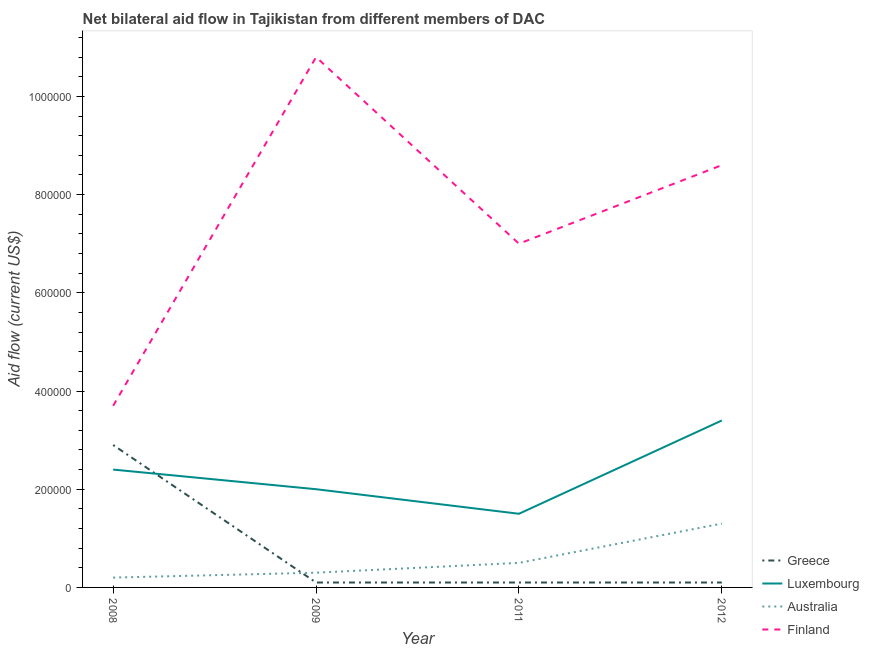Does the line corresponding to amount of aid given by finland intersect with the line corresponding to amount of aid given by luxembourg?
Your response must be concise. No. What is the amount of aid given by luxembourg in 2012?
Give a very brief answer. 3.40e+05. Across all years, what is the maximum amount of aid given by australia?
Keep it short and to the point. 1.30e+05. Across all years, what is the minimum amount of aid given by greece?
Your answer should be very brief. 10000. In which year was the amount of aid given by australia maximum?
Your answer should be very brief. 2012. What is the total amount of aid given by greece in the graph?
Make the answer very short. 3.20e+05. What is the difference between the amount of aid given by greece in 2008 and that in 2009?
Give a very brief answer. 2.80e+05. What is the difference between the amount of aid given by greece in 2009 and the amount of aid given by finland in 2008?
Provide a succinct answer. -3.60e+05. What is the average amount of aid given by australia per year?
Make the answer very short. 5.75e+04. In the year 2009, what is the difference between the amount of aid given by greece and amount of aid given by luxembourg?
Ensure brevity in your answer.  -1.90e+05. What is the ratio of the amount of aid given by finland in 2008 to that in 2009?
Offer a very short reply. 0.34. Is the amount of aid given by luxembourg in 2009 less than that in 2012?
Offer a very short reply. Yes. Is the difference between the amount of aid given by australia in 2009 and 2011 greater than the difference between the amount of aid given by greece in 2009 and 2011?
Offer a very short reply. No. What is the difference between the highest and the second highest amount of aid given by finland?
Provide a succinct answer. 2.20e+05. What is the difference between the highest and the lowest amount of aid given by luxembourg?
Ensure brevity in your answer.  1.90e+05. Is the sum of the amount of aid given by greece in 2009 and 2011 greater than the maximum amount of aid given by australia across all years?
Give a very brief answer. No. Is it the case that in every year, the sum of the amount of aid given by greece and amount of aid given by australia is greater than the sum of amount of aid given by luxembourg and amount of aid given by finland?
Provide a succinct answer. Yes. Does the amount of aid given by australia monotonically increase over the years?
Offer a very short reply. Yes. Is the amount of aid given by australia strictly greater than the amount of aid given by luxembourg over the years?
Your response must be concise. No. Is the amount of aid given by luxembourg strictly less than the amount of aid given by greece over the years?
Your response must be concise. No. How many years are there in the graph?
Ensure brevity in your answer.  4. What is the difference between two consecutive major ticks on the Y-axis?
Offer a very short reply. 2.00e+05. Does the graph contain any zero values?
Your response must be concise. No. Does the graph contain grids?
Offer a very short reply. No. How many legend labels are there?
Ensure brevity in your answer.  4. How are the legend labels stacked?
Provide a short and direct response. Vertical. What is the title of the graph?
Ensure brevity in your answer.  Net bilateral aid flow in Tajikistan from different members of DAC. What is the label or title of the Y-axis?
Offer a very short reply. Aid flow (current US$). What is the Aid flow (current US$) of Greece in 2008?
Ensure brevity in your answer.  2.90e+05. What is the Aid flow (current US$) in Luxembourg in 2008?
Your response must be concise. 2.40e+05. What is the Aid flow (current US$) of Finland in 2008?
Ensure brevity in your answer.  3.70e+05. What is the Aid flow (current US$) of Greece in 2009?
Ensure brevity in your answer.  10000. What is the Aid flow (current US$) of Australia in 2009?
Give a very brief answer. 3.00e+04. What is the Aid flow (current US$) of Finland in 2009?
Make the answer very short. 1.08e+06. What is the Aid flow (current US$) of Finland in 2011?
Ensure brevity in your answer.  7.00e+05. What is the Aid flow (current US$) in Greece in 2012?
Provide a succinct answer. 10000. What is the Aid flow (current US$) of Finland in 2012?
Ensure brevity in your answer.  8.60e+05. Across all years, what is the maximum Aid flow (current US$) of Luxembourg?
Offer a very short reply. 3.40e+05. Across all years, what is the maximum Aid flow (current US$) in Finland?
Give a very brief answer. 1.08e+06. Across all years, what is the minimum Aid flow (current US$) in Greece?
Offer a terse response. 10000. What is the total Aid flow (current US$) in Luxembourg in the graph?
Give a very brief answer. 9.30e+05. What is the total Aid flow (current US$) of Australia in the graph?
Make the answer very short. 2.30e+05. What is the total Aid flow (current US$) of Finland in the graph?
Your answer should be very brief. 3.01e+06. What is the difference between the Aid flow (current US$) of Finland in 2008 and that in 2009?
Your answer should be very brief. -7.10e+05. What is the difference between the Aid flow (current US$) in Greece in 2008 and that in 2011?
Provide a succinct answer. 2.80e+05. What is the difference between the Aid flow (current US$) of Luxembourg in 2008 and that in 2011?
Ensure brevity in your answer.  9.00e+04. What is the difference between the Aid flow (current US$) of Australia in 2008 and that in 2011?
Provide a succinct answer. -3.00e+04. What is the difference between the Aid flow (current US$) in Finland in 2008 and that in 2011?
Provide a short and direct response. -3.30e+05. What is the difference between the Aid flow (current US$) of Luxembourg in 2008 and that in 2012?
Make the answer very short. -1.00e+05. What is the difference between the Aid flow (current US$) in Australia in 2008 and that in 2012?
Your answer should be compact. -1.10e+05. What is the difference between the Aid flow (current US$) in Finland in 2008 and that in 2012?
Your response must be concise. -4.90e+05. What is the difference between the Aid flow (current US$) of Greece in 2009 and that in 2011?
Give a very brief answer. 0. What is the difference between the Aid flow (current US$) of Finland in 2009 and that in 2011?
Your response must be concise. 3.80e+05. What is the difference between the Aid flow (current US$) in Luxembourg in 2009 and that in 2012?
Your answer should be compact. -1.40e+05. What is the difference between the Aid flow (current US$) in Australia in 2009 and that in 2012?
Provide a short and direct response. -1.00e+05. What is the difference between the Aid flow (current US$) of Finland in 2009 and that in 2012?
Offer a very short reply. 2.20e+05. What is the difference between the Aid flow (current US$) in Greece in 2011 and that in 2012?
Offer a very short reply. 0. What is the difference between the Aid flow (current US$) in Luxembourg in 2011 and that in 2012?
Your response must be concise. -1.90e+05. What is the difference between the Aid flow (current US$) of Finland in 2011 and that in 2012?
Ensure brevity in your answer.  -1.60e+05. What is the difference between the Aid flow (current US$) in Greece in 2008 and the Aid flow (current US$) in Luxembourg in 2009?
Your answer should be very brief. 9.00e+04. What is the difference between the Aid flow (current US$) of Greece in 2008 and the Aid flow (current US$) of Australia in 2009?
Offer a very short reply. 2.60e+05. What is the difference between the Aid flow (current US$) in Greece in 2008 and the Aid flow (current US$) in Finland in 2009?
Offer a terse response. -7.90e+05. What is the difference between the Aid flow (current US$) in Luxembourg in 2008 and the Aid flow (current US$) in Australia in 2009?
Your answer should be very brief. 2.10e+05. What is the difference between the Aid flow (current US$) of Luxembourg in 2008 and the Aid flow (current US$) of Finland in 2009?
Your answer should be very brief. -8.40e+05. What is the difference between the Aid flow (current US$) of Australia in 2008 and the Aid flow (current US$) of Finland in 2009?
Provide a short and direct response. -1.06e+06. What is the difference between the Aid flow (current US$) of Greece in 2008 and the Aid flow (current US$) of Luxembourg in 2011?
Offer a terse response. 1.40e+05. What is the difference between the Aid flow (current US$) in Greece in 2008 and the Aid flow (current US$) in Australia in 2011?
Provide a short and direct response. 2.40e+05. What is the difference between the Aid flow (current US$) of Greece in 2008 and the Aid flow (current US$) of Finland in 2011?
Your answer should be very brief. -4.10e+05. What is the difference between the Aid flow (current US$) of Luxembourg in 2008 and the Aid flow (current US$) of Australia in 2011?
Make the answer very short. 1.90e+05. What is the difference between the Aid flow (current US$) in Luxembourg in 2008 and the Aid flow (current US$) in Finland in 2011?
Your response must be concise. -4.60e+05. What is the difference between the Aid flow (current US$) in Australia in 2008 and the Aid flow (current US$) in Finland in 2011?
Offer a very short reply. -6.80e+05. What is the difference between the Aid flow (current US$) of Greece in 2008 and the Aid flow (current US$) of Luxembourg in 2012?
Ensure brevity in your answer.  -5.00e+04. What is the difference between the Aid flow (current US$) in Greece in 2008 and the Aid flow (current US$) in Finland in 2012?
Your answer should be compact. -5.70e+05. What is the difference between the Aid flow (current US$) in Luxembourg in 2008 and the Aid flow (current US$) in Australia in 2012?
Your response must be concise. 1.10e+05. What is the difference between the Aid flow (current US$) of Luxembourg in 2008 and the Aid flow (current US$) of Finland in 2012?
Make the answer very short. -6.20e+05. What is the difference between the Aid flow (current US$) in Australia in 2008 and the Aid flow (current US$) in Finland in 2012?
Ensure brevity in your answer.  -8.40e+05. What is the difference between the Aid flow (current US$) in Greece in 2009 and the Aid flow (current US$) in Finland in 2011?
Your response must be concise. -6.90e+05. What is the difference between the Aid flow (current US$) of Luxembourg in 2009 and the Aid flow (current US$) of Australia in 2011?
Ensure brevity in your answer.  1.50e+05. What is the difference between the Aid flow (current US$) in Luxembourg in 2009 and the Aid flow (current US$) in Finland in 2011?
Offer a very short reply. -5.00e+05. What is the difference between the Aid flow (current US$) in Australia in 2009 and the Aid flow (current US$) in Finland in 2011?
Your response must be concise. -6.70e+05. What is the difference between the Aid flow (current US$) of Greece in 2009 and the Aid flow (current US$) of Luxembourg in 2012?
Your answer should be very brief. -3.30e+05. What is the difference between the Aid flow (current US$) in Greece in 2009 and the Aid flow (current US$) in Finland in 2012?
Your answer should be compact. -8.50e+05. What is the difference between the Aid flow (current US$) in Luxembourg in 2009 and the Aid flow (current US$) in Finland in 2012?
Your answer should be very brief. -6.60e+05. What is the difference between the Aid flow (current US$) in Australia in 2009 and the Aid flow (current US$) in Finland in 2012?
Make the answer very short. -8.30e+05. What is the difference between the Aid flow (current US$) in Greece in 2011 and the Aid flow (current US$) in Luxembourg in 2012?
Give a very brief answer. -3.30e+05. What is the difference between the Aid flow (current US$) of Greece in 2011 and the Aid flow (current US$) of Australia in 2012?
Give a very brief answer. -1.20e+05. What is the difference between the Aid flow (current US$) of Greece in 2011 and the Aid flow (current US$) of Finland in 2012?
Your response must be concise. -8.50e+05. What is the difference between the Aid flow (current US$) in Luxembourg in 2011 and the Aid flow (current US$) in Australia in 2012?
Ensure brevity in your answer.  2.00e+04. What is the difference between the Aid flow (current US$) of Luxembourg in 2011 and the Aid flow (current US$) of Finland in 2012?
Keep it short and to the point. -7.10e+05. What is the difference between the Aid flow (current US$) of Australia in 2011 and the Aid flow (current US$) of Finland in 2012?
Your response must be concise. -8.10e+05. What is the average Aid flow (current US$) in Luxembourg per year?
Your answer should be very brief. 2.32e+05. What is the average Aid flow (current US$) in Australia per year?
Your answer should be compact. 5.75e+04. What is the average Aid flow (current US$) in Finland per year?
Your answer should be very brief. 7.52e+05. In the year 2008, what is the difference between the Aid flow (current US$) in Greece and Aid flow (current US$) in Luxembourg?
Your answer should be compact. 5.00e+04. In the year 2008, what is the difference between the Aid flow (current US$) in Greece and Aid flow (current US$) in Australia?
Your answer should be compact. 2.70e+05. In the year 2008, what is the difference between the Aid flow (current US$) in Greece and Aid flow (current US$) in Finland?
Your answer should be compact. -8.00e+04. In the year 2008, what is the difference between the Aid flow (current US$) of Luxembourg and Aid flow (current US$) of Australia?
Make the answer very short. 2.20e+05. In the year 2008, what is the difference between the Aid flow (current US$) in Australia and Aid flow (current US$) in Finland?
Give a very brief answer. -3.50e+05. In the year 2009, what is the difference between the Aid flow (current US$) of Greece and Aid flow (current US$) of Luxembourg?
Make the answer very short. -1.90e+05. In the year 2009, what is the difference between the Aid flow (current US$) in Greece and Aid flow (current US$) in Finland?
Provide a succinct answer. -1.07e+06. In the year 2009, what is the difference between the Aid flow (current US$) of Luxembourg and Aid flow (current US$) of Finland?
Provide a succinct answer. -8.80e+05. In the year 2009, what is the difference between the Aid flow (current US$) of Australia and Aid flow (current US$) of Finland?
Give a very brief answer. -1.05e+06. In the year 2011, what is the difference between the Aid flow (current US$) in Greece and Aid flow (current US$) in Australia?
Your answer should be very brief. -4.00e+04. In the year 2011, what is the difference between the Aid flow (current US$) in Greece and Aid flow (current US$) in Finland?
Make the answer very short. -6.90e+05. In the year 2011, what is the difference between the Aid flow (current US$) in Luxembourg and Aid flow (current US$) in Finland?
Offer a very short reply. -5.50e+05. In the year 2011, what is the difference between the Aid flow (current US$) of Australia and Aid flow (current US$) of Finland?
Provide a short and direct response. -6.50e+05. In the year 2012, what is the difference between the Aid flow (current US$) of Greece and Aid flow (current US$) of Luxembourg?
Provide a short and direct response. -3.30e+05. In the year 2012, what is the difference between the Aid flow (current US$) of Greece and Aid flow (current US$) of Finland?
Offer a very short reply. -8.50e+05. In the year 2012, what is the difference between the Aid flow (current US$) in Luxembourg and Aid flow (current US$) in Finland?
Your answer should be very brief. -5.20e+05. In the year 2012, what is the difference between the Aid flow (current US$) in Australia and Aid flow (current US$) in Finland?
Make the answer very short. -7.30e+05. What is the ratio of the Aid flow (current US$) of Australia in 2008 to that in 2009?
Offer a very short reply. 0.67. What is the ratio of the Aid flow (current US$) in Finland in 2008 to that in 2009?
Provide a short and direct response. 0.34. What is the ratio of the Aid flow (current US$) of Luxembourg in 2008 to that in 2011?
Keep it short and to the point. 1.6. What is the ratio of the Aid flow (current US$) in Australia in 2008 to that in 2011?
Give a very brief answer. 0.4. What is the ratio of the Aid flow (current US$) in Finland in 2008 to that in 2011?
Your answer should be very brief. 0.53. What is the ratio of the Aid flow (current US$) in Luxembourg in 2008 to that in 2012?
Your answer should be compact. 0.71. What is the ratio of the Aid flow (current US$) of Australia in 2008 to that in 2012?
Keep it short and to the point. 0.15. What is the ratio of the Aid flow (current US$) in Finland in 2008 to that in 2012?
Your answer should be compact. 0.43. What is the ratio of the Aid flow (current US$) in Luxembourg in 2009 to that in 2011?
Provide a succinct answer. 1.33. What is the ratio of the Aid flow (current US$) in Australia in 2009 to that in 2011?
Provide a short and direct response. 0.6. What is the ratio of the Aid flow (current US$) of Finland in 2009 to that in 2011?
Offer a very short reply. 1.54. What is the ratio of the Aid flow (current US$) of Luxembourg in 2009 to that in 2012?
Ensure brevity in your answer.  0.59. What is the ratio of the Aid flow (current US$) of Australia in 2009 to that in 2012?
Ensure brevity in your answer.  0.23. What is the ratio of the Aid flow (current US$) in Finland in 2009 to that in 2012?
Provide a succinct answer. 1.26. What is the ratio of the Aid flow (current US$) of Greece in 2011 to that in 2012?
Give a very brief answer. 1. What is the ratio of the Aid flow (current US$) in Luxembourg in 2011 to that in 2012?
Make the answer very short. 0.44. What is the ratio of the Aid flow (current US$) of Australia in 2011 to that in 2012?
Ensure brevity in your answer.  0.38. What is the ratio of the Aid flow (current US$) in Finland in 2011 to that in 2012?
Give a very brief answer. 0.81. What is the difference between the highest and the lowest Aid flow (current US$) of Greece?
Give a very brief answer. 2.80e+05. What is the difference between the highest and the lowest Aid flow (current US$) of Luxembourg?
Offer a very short reply. 1.90e+05. What is the difference between the highest and the lowest Aid flow (current US$) in Finland?
Offer a terse response. 7.10e+05. 